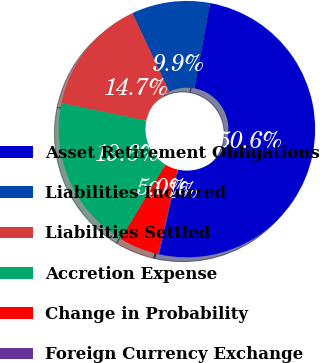Convert chart to OTSL. <chart><loc_0><loc_0><loc_500><loc_500><pie_chart><fcel>Asset Retirement Obligations<fcel>Liabilities Incurred<fcel>Liabilities Settled<fcel>Accretion Expense<fcel>Change in Probability<fcel>Foreign Currency Exchange<nl><fcel>50.61%<fcel>9.88%<fcel>14.75%<fcel>19.63%<fcel>5.0%<fcel>0.13%<nl></chart> 